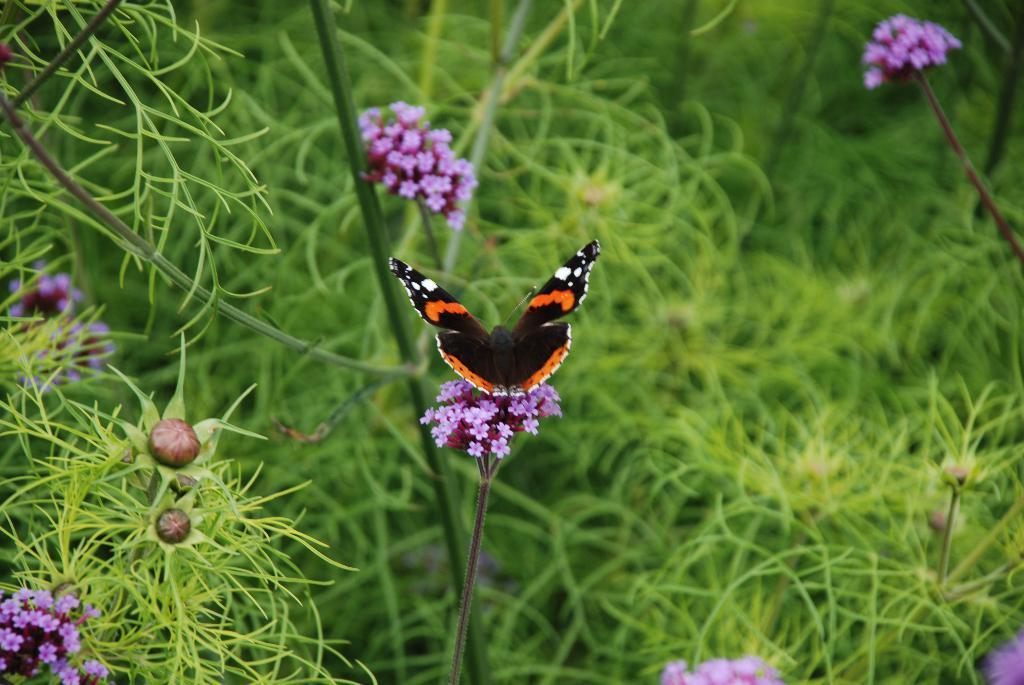Could you give a brief overview of what you see in this image? This picture shows plants with flowers and we see a butterfly. it is black and orange in color with few white dots. 